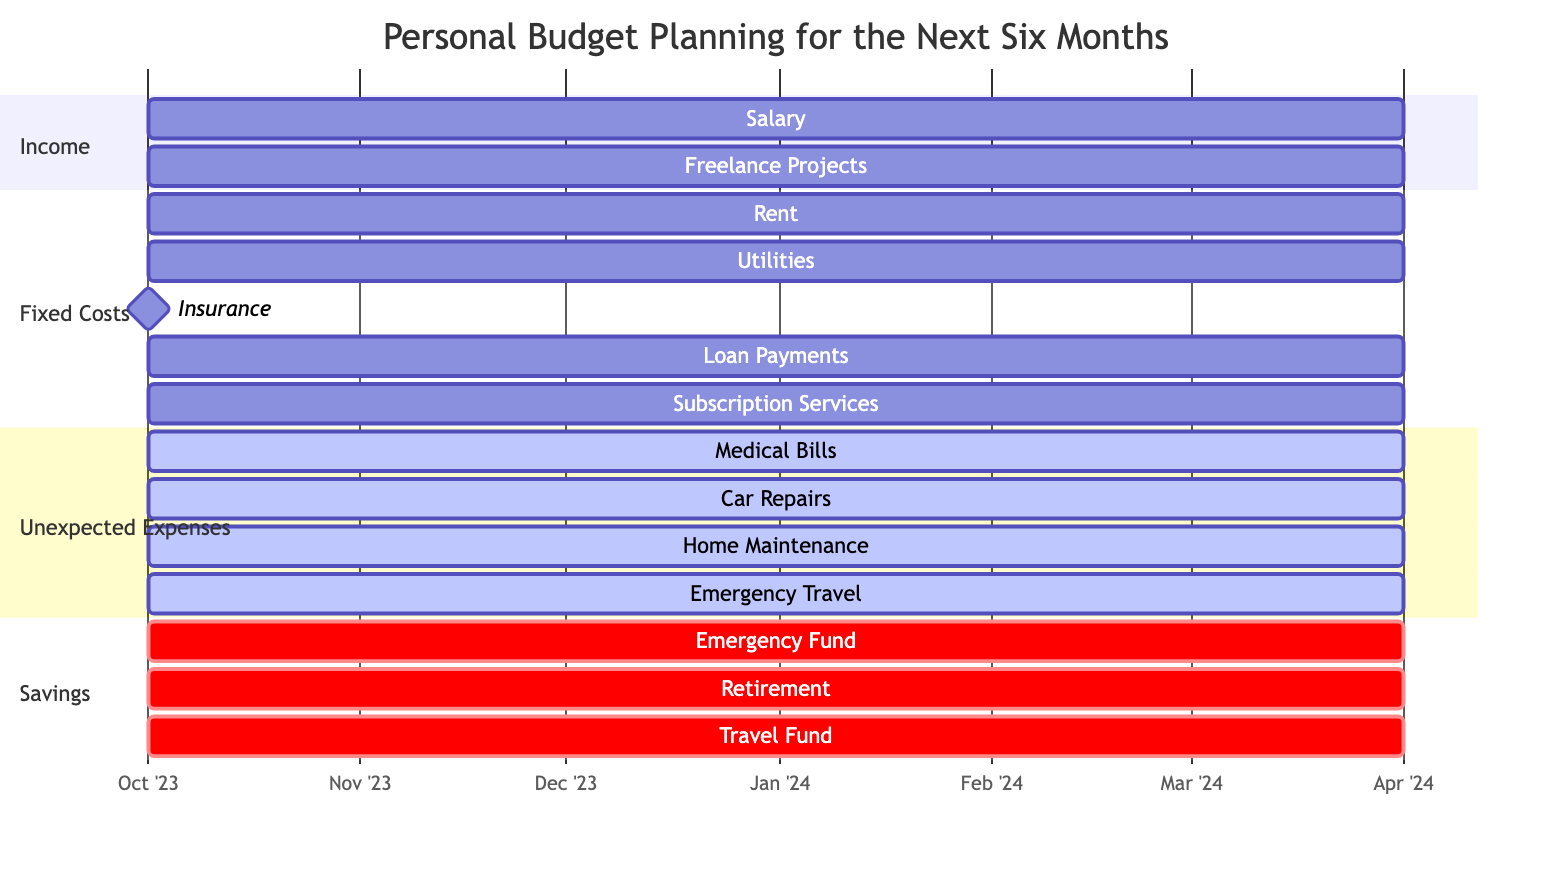What's the duration of the Salary income category? The Salary income category starts in October 2023 and spans for 6 months, which includes October, November, December, January, February, and March.
Answer: 6 months How many segments are under Fixed Costs? The Fixed Costs section has 5 categories listed: Rent, Utilities, Insurance, Loan Payments, and Subscription Services.
Answer: 5 Which category has a milestone status? The diagram indicates that Insurance is marked as a milestone, which signifies its unique timing as it is an annual expense rather than a monthly one like others.
Answer: Insurance What is the start month for Unexpected Expenses? The Unexpected Expenses section lists all categories beginning in October 2023, marking this as the start month for all listed expenses.
Answer: October 2023 Which savings category is labeled as critical? All savings categories: Emergency Fund, Retirement, and Travel Fund are marked as critical, indicating their importance for financial planning.
Answer: Emergency Fund, Retirement, Travel Fund How many months do the Fixed Costs extend? The Fixed Costs section shows that all categories extend from October 2023 to March 2024, covering a total of 6 months.
Answer: 6 months Are Car Repairs and Medical Bills categorized under Monthly or Predictive? Both Car Repairs and Medical Bills fall under the Predictive category in Unexpected Expenses, suggesting that these are anticipated expenses rather than fixed monthly obligations.
Answer: Predictive What is the total number of segments in the entire diagram? The diagram consists of four main sections: Income, Fixed Costs, Unexpected Expenses, and Savings, each containing multiple categories, leading to a total of 15 segments.
Answer: 15 segments 